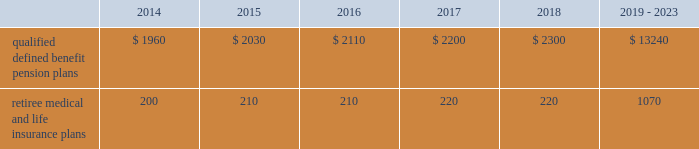Valuation techniques 2013 cash equivalents are mostly comprised of short-term money-market instruments and are valued at cost , which approximates fair value .
U.s .
Equity securities and international equity securities categorized as level 1 are traded on active national and international exchanges and are valued at their closing prices on the last trading day of the year .
For u.s .
Equity securities and international equity securities not traded on an active exchange , or if the closing price is not available , the trustee obtains indicative quotes from a pricing vendor , broker , or investment manager .
These securities are categorized as level 2 if the custodian obtains corroborated quotes from a pricing vendor or categorized as level 3 if the custodian obtains uncorroborated quotes from a broker or investment manager .
Commingled equity funds are investment vehicles valued using the net asset value ( nav ) provided by the fund managers .
The nav is the total value of the fund divided by the number of shares outstanding .
Commingled equity funds are categorized as level 1 if traded at their nav on a nationally recognized securities exchange or categorized as level 2 if the nav is corroborated by observable market data ( e.g. , purchases or sales activity ) and we are able to redeem our investment in the near-term .
Fixed income investments categorized as level 2 are valued by the trustee using pricing models that use verifiable observable market data ( e.g. , interest rates and yield curves observable at commonly quoted intervals and credit spreads ) , bids provided by brokers or dealers , or quoted prices of securities with similar characteristics .
Fixed income investments are categorized at level 3 when valuations using observable inputs are unavailable .
The trustee obtains pricing based on indicative quotes or bid evaluations from vendors , brokers , or the investment manager .
Private equity funds , real estate funds , and hedge funds are valued using the nav based on valuation models of underlying securities which generally include significant unobservable inputs that cannot be corroborated using verifiable observable market data .
Valuations for private equity funds and real estate funds are determined by the general partners .
Depending on the nature of the assets , the general partners may use various valuation methodologies , including the income and market approaches in their models .
The market approach consists of analyzing market transactions for comparable assets while the income approach uses earnings or the net present value of estimated future cash flows adjusted for liquidity and other risk factors .
Hedge funds are valued by independent administrators using various pricing sources and models based on the nature of the securities .
Private equity funds , real estate funds , and hedge funds are generally categorized as level 3 as we cannot fully redeem our investment in the near-term .
Commodities are traded on an active commodity exchange and are valued at their closing prices on the last trading day of the year .
Contributions and expected benefit payments we generally determine funding requirements for our defined benefit pension plans in a manner consistent with cas and internal revenue code rules .
In 2013 , we made contributions of $ 2.25 billion related to our qualified defined benefit pension plans .
We currently plan to make contributions of approximately $ 1.0 billion related to the qualified defined benefit pension plans in 2014 .
In 2013 , we made contributions of $ 98 million to our retiree medical and life insurance plans .
We do not expect to make contributions related to the retiree medical and life insurance plans in 2014 as a result of our 2013 contributions .
The table presents estimated future benefit payments , which reflect expected future employee service , as of december 31 , 2013 ( in millions ) : .
Defined contribution plans we maintain a number of defined contribution plans , most with 401 ( k ) features , that cover substantially all of our employees .
Under the provisions of our 401 ( k ) plans , we match most employees 2019 eligible contributions at rates specified in the plan documents .
Our contributions were $ 383 million in 2013 , $ 380 million in 2012 , and $ 378 million in 2011 , the majority of which were funded in our common stock .
Our defined contribution plans held approximately 44.7 million and 48.6 million shares of our common stock as of december 31 , 2013 and 2012. .
What is the change in estimated future benefit payments , which reflect expected future employee service , as of december 31 , 2013 , from 2014 to 2015 in millions? 
Computations: (2030 - 1960)
Answer: 70.0. 